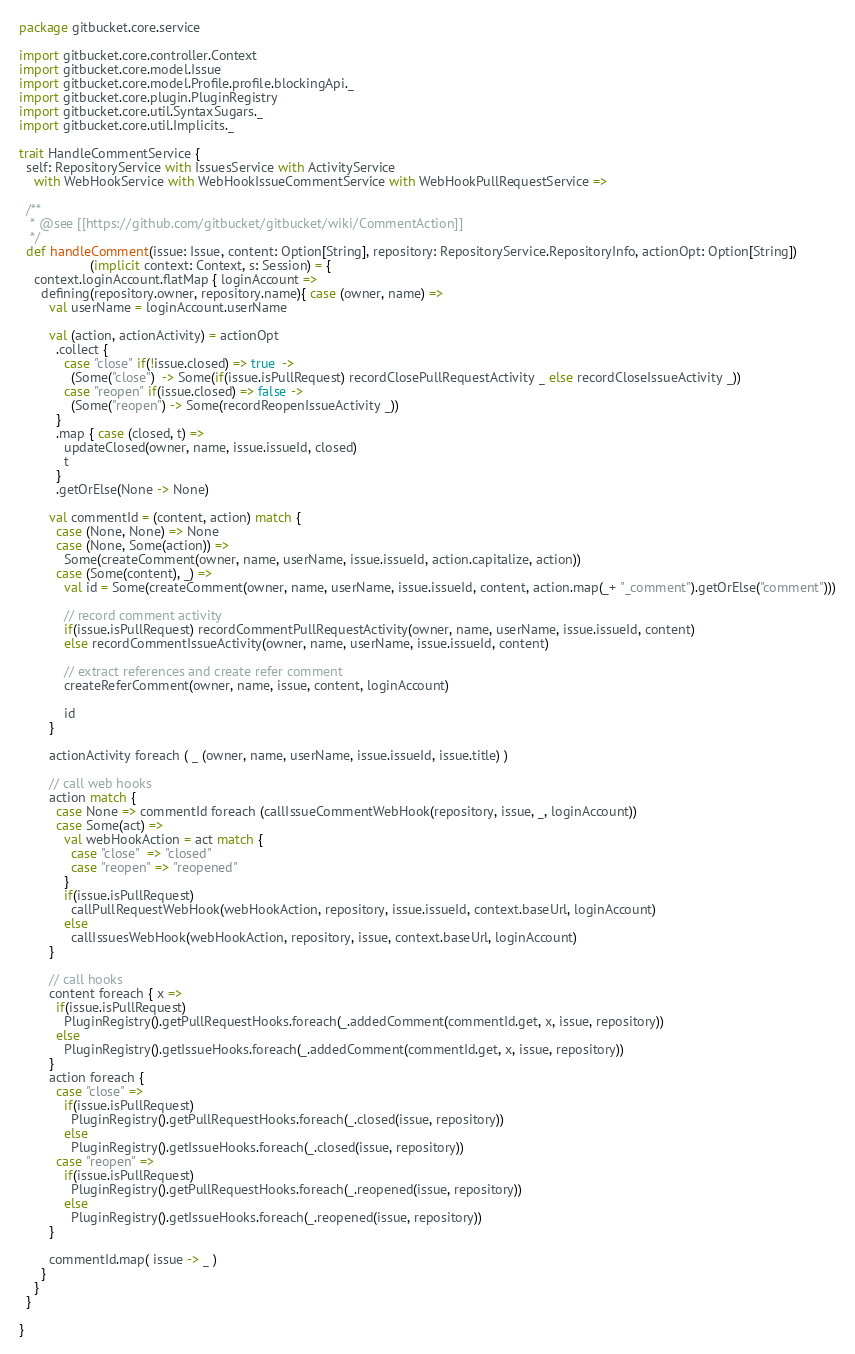Convert code to text. <code><loc_0><loc_0><loc_500><loc_500><_Scala_>package gitbucket.core.service

import gitbucket.core.controller.Context
import gitbucket.core.model.Issue
import gitbucket.core.model.Profile.profile.blockingApi._
import gitbucket.core.plugin.PluginRegistry
import gitbucket.core.util.SyntaxSugars._
import gitbucket.core.util.Implicits._

trait HandleCommentService {
  self: RepositoryService with IssuesService with ActivityService
    with WebHookService with WebHookIssueCommentService with WebHookPullRequestService =>

  /**
   * @see [[https://github.com/gitbucket/gitbucket/wiki/CommentAction]]
   */
  def handleComment(issue: Issue, content: Option[String], repository: RepositoryService.RepositoryInfo, actionOpt: Option[String])
                   (implicit context: Context, s: Session) = {
    context.loginAccount.flatMap { loginAccount =>
      defining(repository.owner, repository.name){ case (owner, name) =>
        val userName = loginAccount.userName

        val (action, actionActivity) = actionOpt
          .collect {
            case "close" if(!issue.closed) => true  ->
              (Some("close")  -> Some(if(issue.isPullRequest) recordClosePullRequestActivity _ else recordCloseIssueActivity _))
            case "reopen" if(issue.closed) => false ->
              (Some("reopen") -> Some(recordReopenIssueActivity _))
          }
          .map { case (closed, t) =>
            updateClosed(owner, name, issue.issueId, closed)
            t
          }
          .getOrElse(None -> None)

        val commentId = (content, action) match {
          case (None, None) => None
          case (None, Some(action)) =>
            Some(createComment(owner, name, userName, issue.issueId, action.capitalize, action))
          case (Some(content), _) =>
            val id = Some(createComment(owner, name, userName, issue.issueId, content, action.map(_+ "_comment").getOrElse("comment")))

            // record comment activity
            if(issue.isPullRequest) recordCommentPullRequestActivity(owner, name, userName, issue.issueId, content)
            else recordCommentIssueActivity(owner, name, userName, issue.issueId, content)

            // extract references and create refer comment
            createReferComment(owner, name, issue, content, loginAccount)

            id
        }

        actionActivity foreach ( _ (owner, name, userName, issue.issueId, issue.title) )

        // call web hooks
        action match {
          case None => commentId foreach (callIssueCommentWebHook(repository, issue, _, loginAccount))
          case Some(act) =>
            val webHookAction = act match {
              case "close"  => "closed"
              case "reopen" => "reopened"
            }
            if(issue.isPullRequest)
              callPullRequestWebHook(webHookAction, repository, issue.issueId, context.baseUrl, loginAccount)
            else
              callIssuesWebHook(webHookAction, repository, issue, context.baseUrl, loginAccount)
        }

        // call hooks
        content foreach { x =>
          if(issue.isPullRequest)
            PluginRegistry().getPullRequestHooks.foreach(_.addedComment(commentId.get, x, issue, repository))
          else
            PluginRegistry().getIssueHooks.foreach(_.addedComment(commentId.get, x, issue, repository))
        }
        action foreach {
          case "close" =>
            if(issue.isPullRequest)
              PluginRegistry().getPullRequestHooks.foreach(_.closed(issue, repository))
            else
              PluginRegistry().getIssueHooks.foreach(_.closed(issue, repository))
          case "reopen" =>
            if(issue.isPullRequest)
              PluginRegistry().getPullRequestHooks.foreach(_.reopened(issue, repository))
            else
              PluginRegistry().getIssueHooks.foreach(_.reopened(issue, repository))
        }

        commentId.map( issue -> _ )
      }
    }
  }

}
</code> 